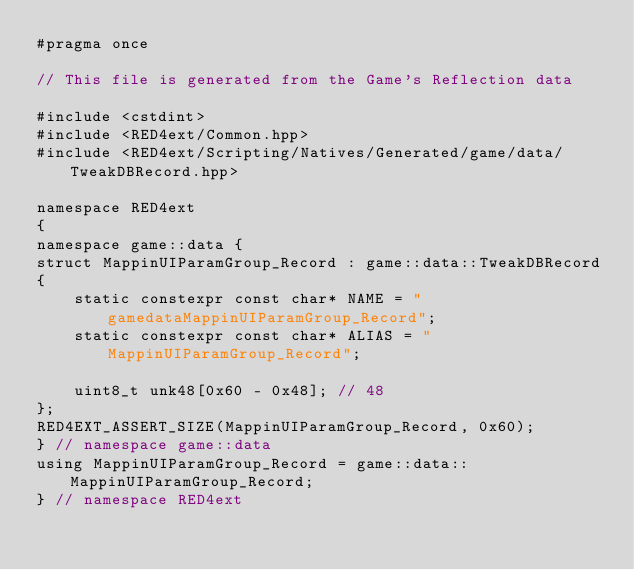<code> <loc_0><loc_0><loc_500><loc_500><_C++_>#pragma once

// This file is generated from the Game's Reflection data

#include <cstdint>
#include <RED4ext/Common.hpp>
#include <RED4ext/Scripting/Natives/Generated/game/data/TweakDBRecord.hpp>

namespace RED4ext
{
namespace game::data { 
struct MappinUIParamGroup_Record : game::data::TweakDBRecord
{
    static constexpr const char* NAME = "gamedataMappinUIParamGroup_Record";
    static constexpr const char* ALIAS = "MappinUIParamGroup_Record";

    uint8_t unk48[0x60 - 0x48]; // 48
};
RED4EXT_ASSERT_SIZE(MappinUIParamGroup_Record, 0x60);
} // namespace game::data
using MappinUIParamGroup_Record = game::data::MappinUIParamGroup_Record;
} // namespace RED4ext
</code> 